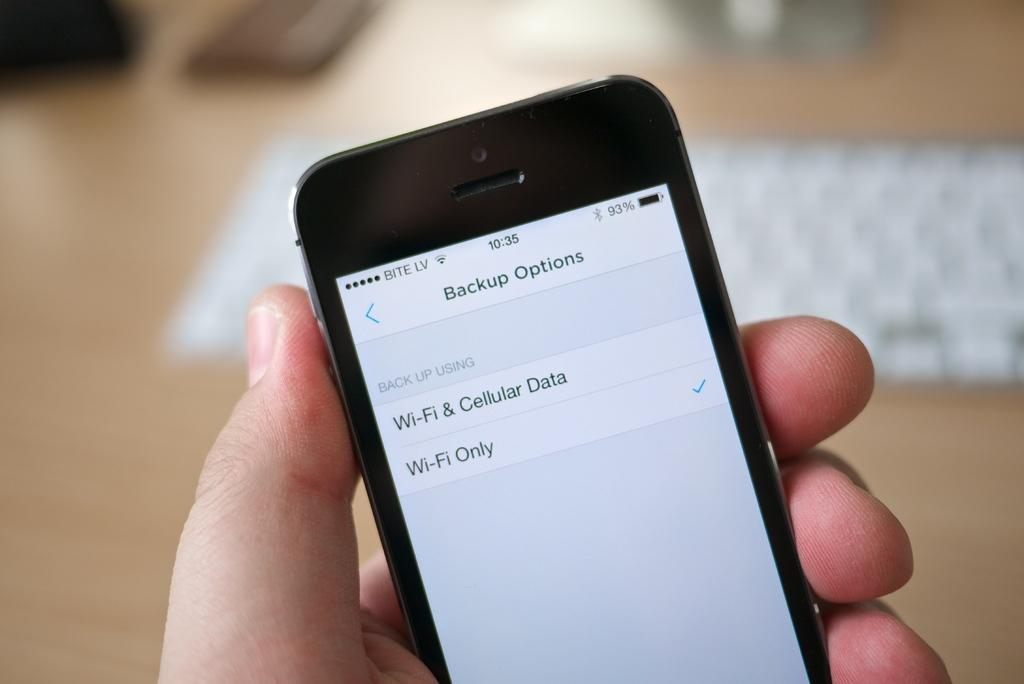<image>
Relay a brief, clear account of the picture shown. An iPhone showing a screen for backup options with Wi-Fi Only option selected. 